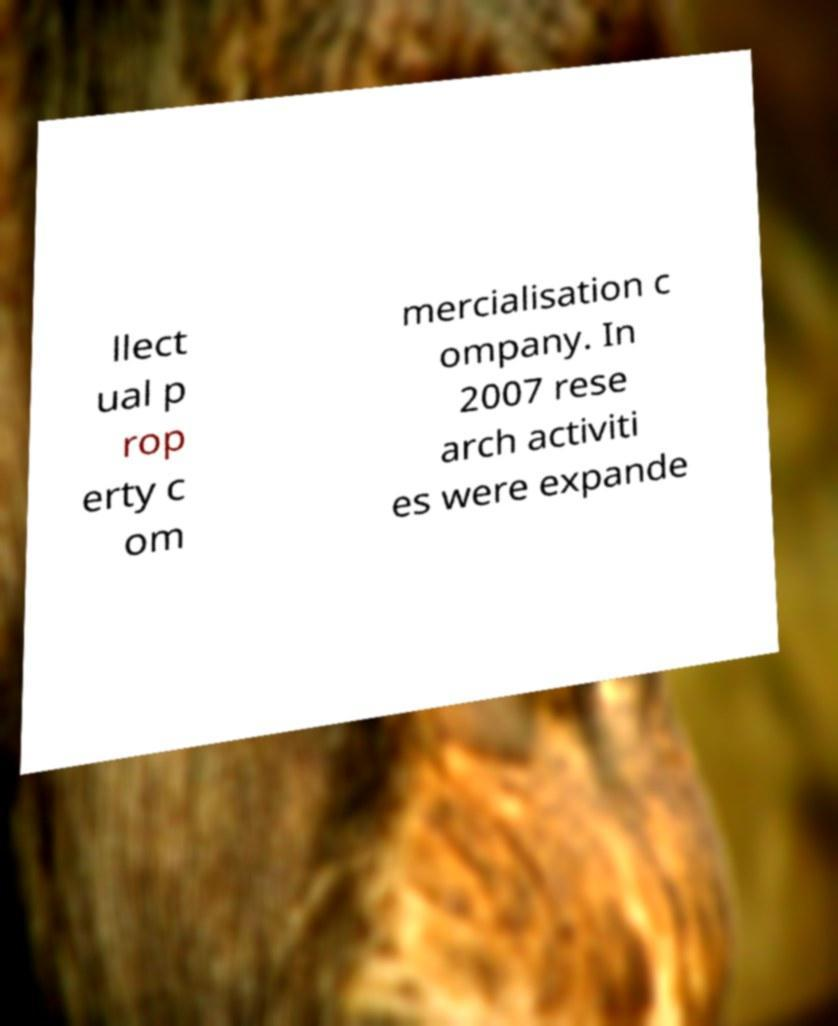For documentation purposes, I need the text within this image transcribed. Could you provide that? llect ual p rop erty c om mercialisation c ompany. In 2007 rese arch activiti es were expande 